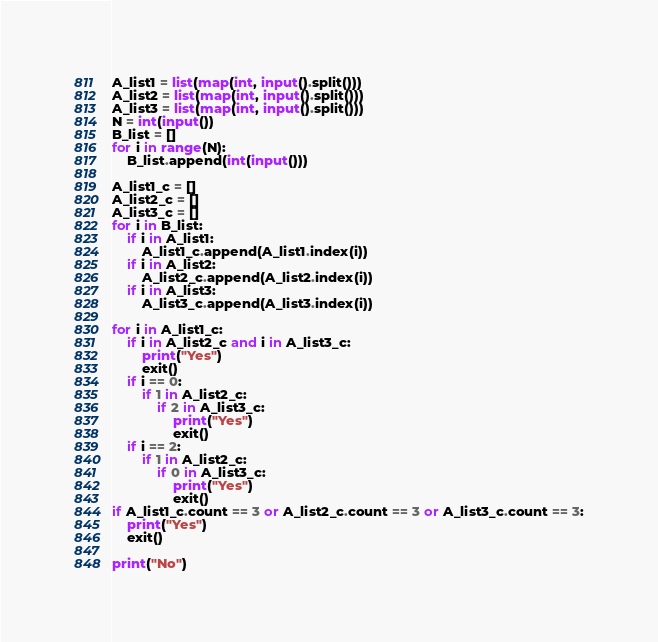<code> <loc_0><loc_0><loc_500><loc_500><_Python_>A_list1 = list(map(int, input().split()))
A_list2 = list(map(int, input().split()))
A_list3 = list(map(int, input().split()))
N = int(input())
B_list = []
for i in range(N):
    B_list.append(int(input()))

A_list1_c = []
A_list2_c = []
A_list3_c = []
for i in B_list:
    if i in A_list1:
        A_list1_c.append(A_list1.index(i))
    if i in A_list2:
        A_list2_c.append(A_list2.index(i))
    if i in A_list3:
        A_list3_c.append(A_list3.index(i))

for i in A_list1_c:
    if i in A_list2_c and i in A_list3_c:
        print("Yes")
        exit()
    if i == 0:
        if 1 in A_list2_c:
            if 2 in A_list3_c:
                print("Yes")
                exit()
    if i == 2:
        if 1 in A_list2_c:
            if 0 in A_list3_c:
                print("Yes")
                exit()
if A_list1_c.count == 3 or A_list2_c.count == 3 or A_list3_c.count == 3:
    print("Yes")
    exit()

print("No")
</code> 